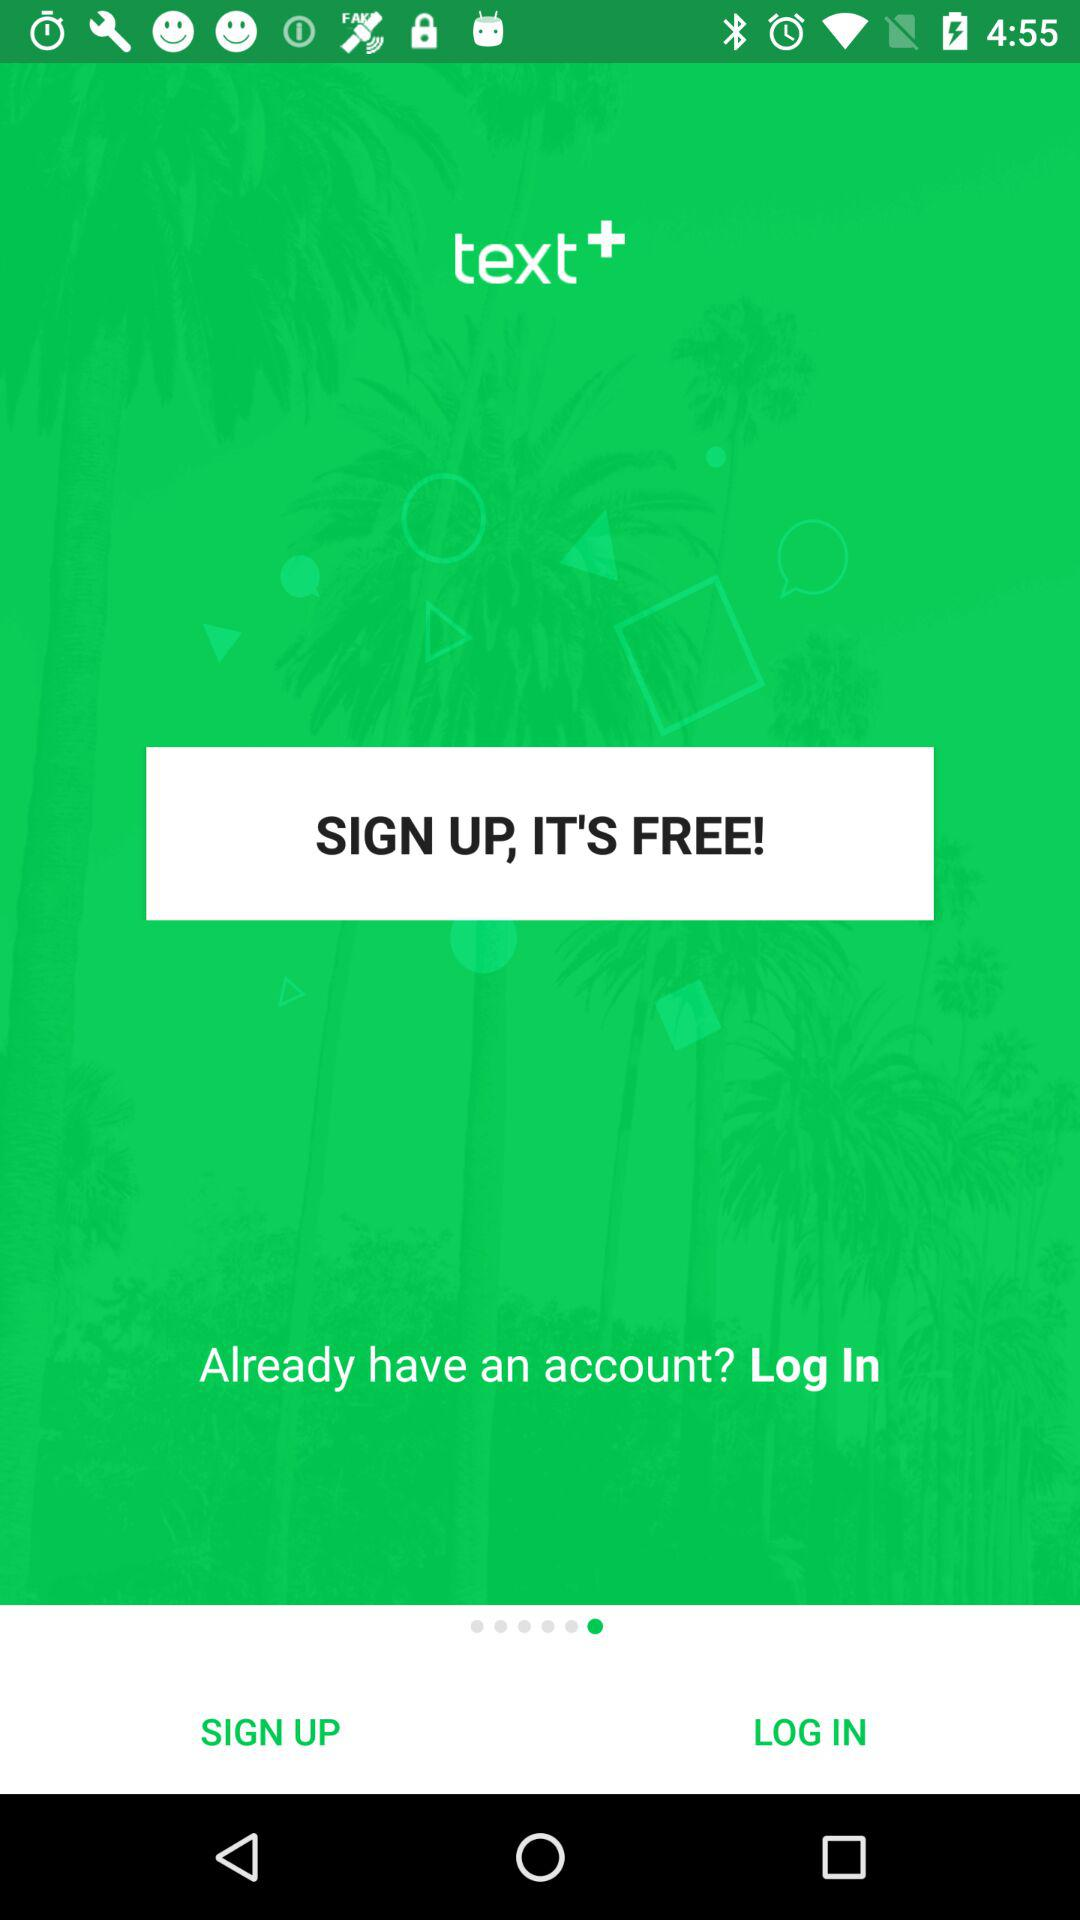What are the requirements to sign up?
When the provided information is insufficient, respond with <no answer>. <no answer> 